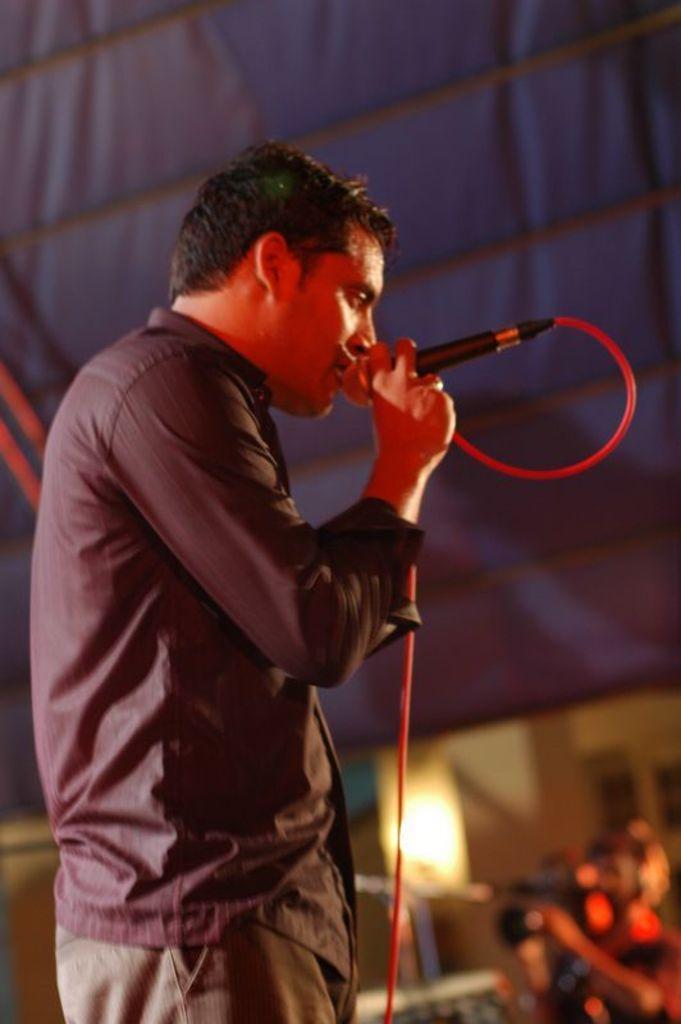Describe this image in one or two sentences. In this image I can see in the middle a person is singing in the microphone, he is wearing the shirt. In the right hand side bottom it looks like a person is holding the camera. 